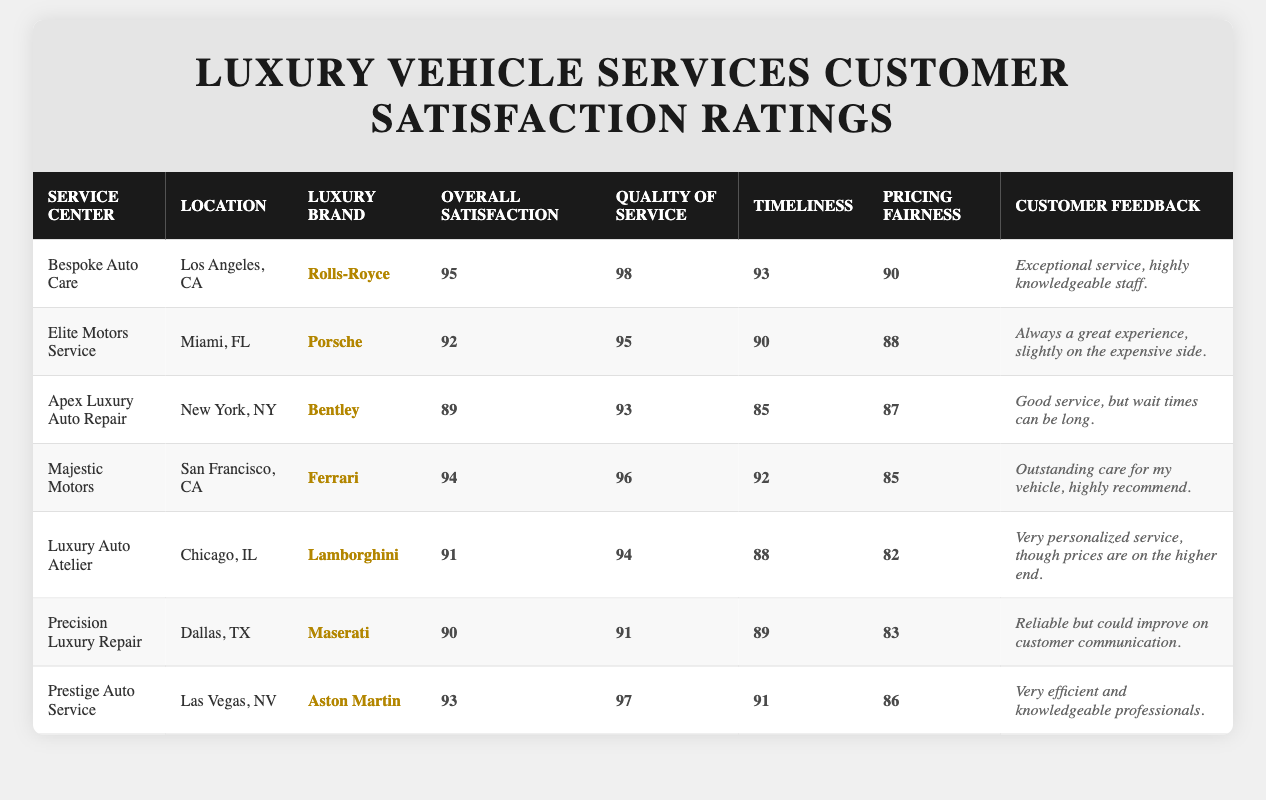What is the overall satisfaction rating for Bespoke Auto Care? The table lists Bespoke Auto Care with an overall satisfaction rating of 95.
Answer: 95 Which service center has the highest quality of service rating? Bespoke Auto Care has the highest quality of service rating of 98 among all service centers listed.
Answer: Bespoke Auto Care What are the customer feedback comments for Precision Luxury Repair? The feedback for Precision Luxury Repair is "Reliable but could improve on customer communication."
Answer: Reliable but could improve on customer communication True or False: Majestic Motors has a lower overall satisfaction rating than Apex Luxury Auto Repair. Majestic Motors has an overall satisfaction rating of 94, while Apex Luxury Auto Repair has a rating of 89. Therefore, the statement is False.
Answer: False What is the average timeliness rating across all service centers? To find the average, sum the timeliness ratings (93 + 90 + 85 + 92 + 88 + 89 + 91 = 618) and divide by the number of service centers (7), giving an average of 618/7 = 88.29.
Answer: 88.29 Which service center has the lowest pricing fairness score, and what is that score? Looking at the table, Luxury Auto Atelier has the lowest pricing fairness score of 82.
Answer: 82 Is the overall satisfaction rating for Aston Martin services higher than that for Porsche services? Aston Martin has a rating of 93, while Porsche has a rating of 92, so yes, the rating for Aston Martin is higher.
Answer: Yes What is the difference in overall satisfaction ratings between Rolls-Royce and Maserati services? Rolls-Royce has an overall satisfaction rating of 95, and Maserati has a rating of 90. The difference is 95 - 90 = 5.
Answer: 5 Which location has the service center with the best overall satisfaction and what is that satisfaction score? Bespoke Auto Care in Los Angeles, CA has the best overall satisfaction score of 95.
Answer: Los Angeles, CA, 95 What percentage of the service centers have an overall satisfaction rating above 90? There are four service centers with ratings above 90 (Bespoke Auto Care, Elite Motors Service, Majestic Motors, and Prestige Auto Service), out of seven total. This is (4/7) * 100 = 57.14%.
Answer: 57.14% 